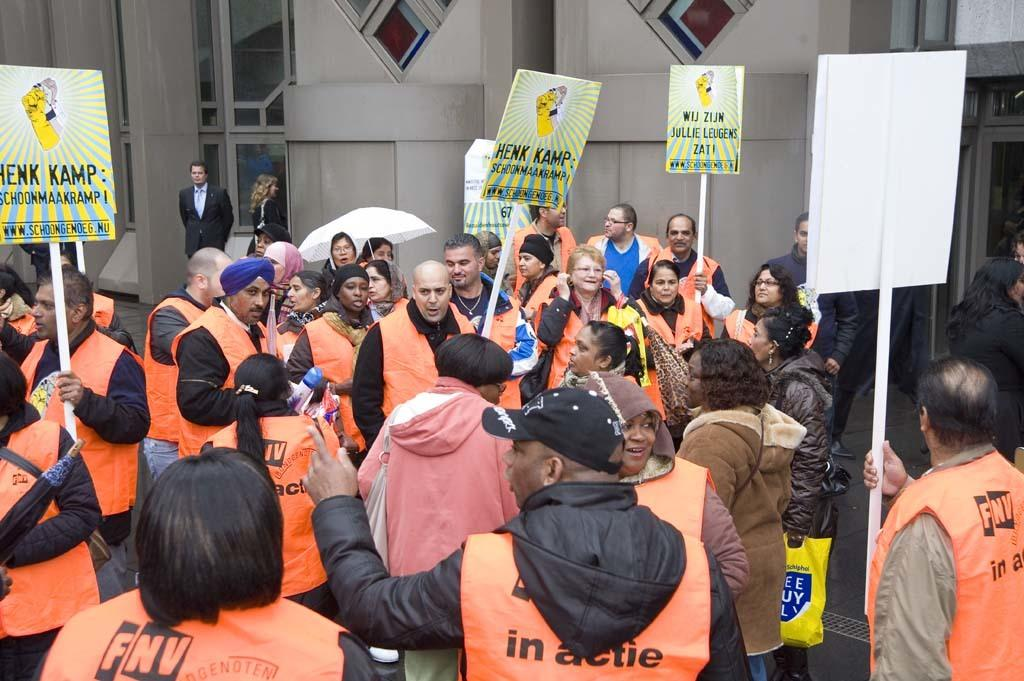<image>
Provide a brief description of the given image. The person closest to the camera has the letters FNV on the back 